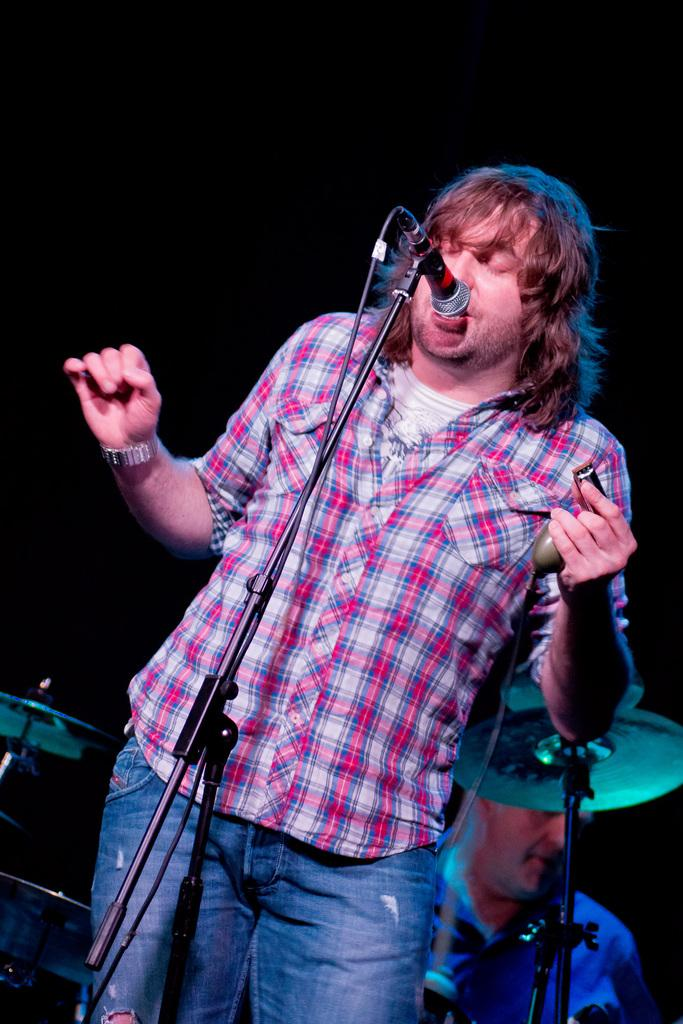What is the main subject of the image? There is a man standing in the image. Where is the man standing? The man is standing on the floor. What is in front of the man? There is a mic placed in front of the man. What can be seen in the background of the image? There are musical instruments and a person sitting in the background of the image. What type of yam is being played by the person sitting in the background? There is no yam present in the image, and the person sitting in the background is not playing any musical instrument. 